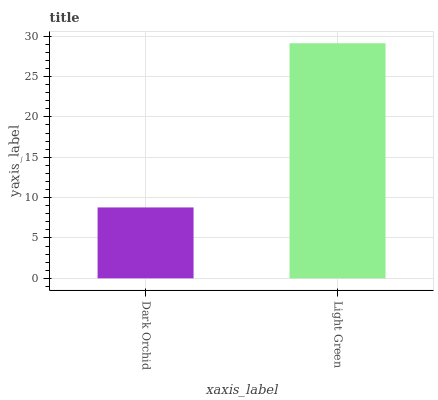Is Dark Orchid the minimum?
Answer yes or no. Yes. Is Light Green the maximum?
Answer yes or no. Yes. Is Light Green the minimum?
Answer yes or no. No. Is Light Green greater than Dark Orchid?
Answer yes or no. Yes. Is Dark Orchid less than Light Green?
Answer yes or no. Yes. Is Dark Orchid greater than Light Green?
Answer yes or no. No. Is Light Green less than Dark Orchid?
Answer yes or no. No. Is Light Green the high median?
Answer yes or no. Yes. Is Dark Orchid the low median?
Answer yes or no. Yes. Is Dark Orchid the high median?
Answer yes or no. No. Is Light Green the low median?
Answer yes or no. No. 